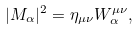Convert formula to latex. <formula><loc_0><loc_0><loc_500><loc_500>| M _ { \alpha } | ^ { 2 } = \eta _ { \mu \nu } W ^ { \mu \nu } _ { \alpha } ,</formula> 